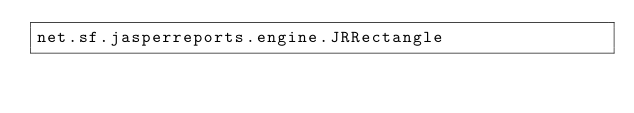Convert code to text. <code><loc_0><loc_0><loc_500><loc_500><_Rust_>net.sf.jasperreports.engine.JRRectangle
</code> 